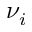<formula> <loc_0><loc_0><loc_500><loc_500>\nu _ { i }</formula> 